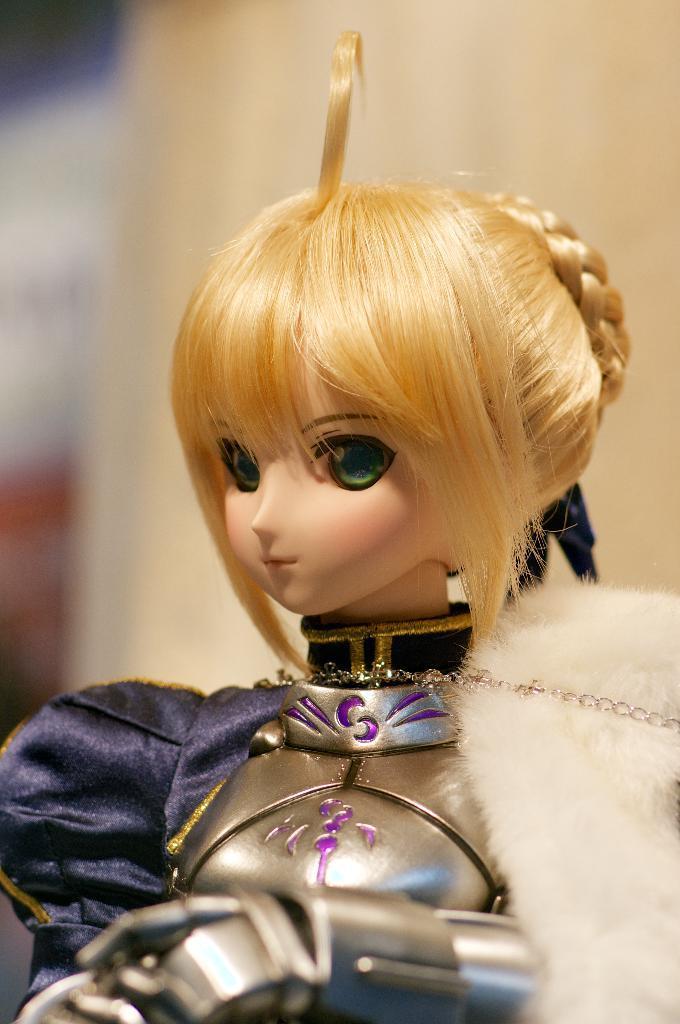Describe this image in one or two sentences. In this image I can see a doll of girl. 